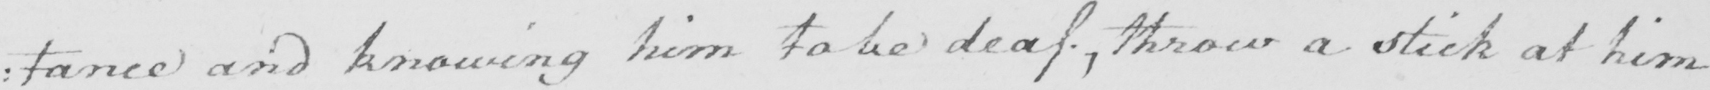Please transcribe the handwritten text in this image. : tance and knowing him to be deaf , throw a stick at him 